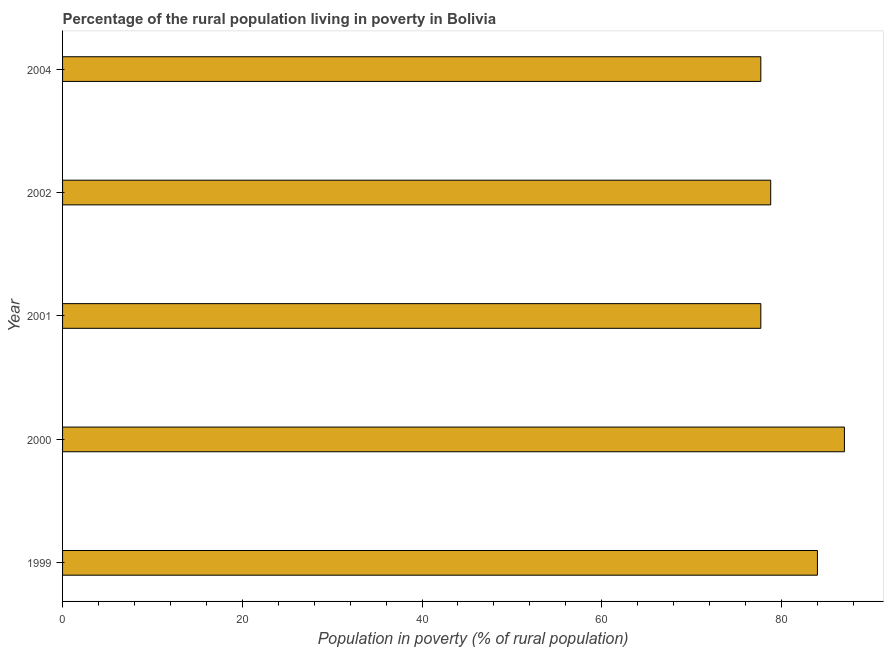What is the title of the graph?
Provide a succinct answer. Percentage of the rural population living in poverty in Bolivia. What is the label or title of the X-axis?
Offer a terse response. Population in poverty (% of rural population). What is the percentage of rural population living below poverty line in 2001?
Your response must be concise. 77.7. Across all years, what is the maximum percentage of rural population living below poverty line?
Provide a succinct answer. 87. Across all years, what is the minimum percentage of rural population living below poverty line?
Provide a succinct answer. 77.7. In which year was the percentage of rural population living below poverty line maximum?
Offer a very short reply. 2000. What is the sum of the percentage of rural population living below poverty line?
Give a very brief answer. 405.2. What is the difference between the percentage of rural population living below poverty line in 2000 and 2004?
Ensure brevity in your answer.  9.3. What is the average percentage of rural population living below poverty line per year?
Your answer should be very brief. 81.04. What is the median percentage of rural population living below poverty line?
Provide a succinct answer. 78.8. Do a majority of the years between 1999 and 2000 (inclusive) have percentage of rural population living below poverty line greater than 44 %?
Offer a very short reply. Yes. What is the ratio of the percentage of rural population living below poverty line in 2001 to that in 2002?
Offer a very short reply. 0.99. Is the percentage of rural population living below poverty line in 2001 less than that in 2002?
Provide a succinct answer. Yes. Is the difference between the percentage of rural population living below poverty line in 1999 and 2000 greater than the difference between any two years?
Give a very brief answer. No. What is the difference between the highest and the second highest percentage of rural population living below poverty line?
Your answer should be compact. 3. Is the sum of the percentage of rural population living below poverty line in 2000 and 2001 greater than the maximum percentage of rural population living below poverty line across all years?
Your response must be concise. Yes. What is the difference between the highest and the lowest percentage of rural population living below poverty line?
Your answer should be compact. 9.3. In how many years, is the percentage of rural population living below poverty line greater than the average percentage of rural population living below poverty line taken over all years?
Your answer should be compact. 2. What is the difference between two consecutive major ticks on the X-axis?
Your answer should be compact. 20. What is the Population in poverty (% of rural population) of 1999?
Offer a very short reply. 84. What is the Population in poverty (% of rural population) of 2001?
Your answer should be compact. 77.7. What is the Population in poverty (% of rural population) of 2002?
Provide a succinct answer. 78.8. What is the Population in poverty (% of rural population) of 2004?
Your answer should be compact. 77.7. What is the difference between the Population in poverty (% of rural population) in 1999 and 2000?
Keep it short and to the point. -3. What is the difference between the Population in poverty (% of rural population) in 2001 and 2004?
Provide a short and direct response. 0. What is the ratio of the Population in poverty (% of rural population) in 1999 to that in 2000?
Offer a terse response. 0.97. What is the ratio of the Population in poverty (% of rural population) in 1999 to that in 2001?
Give a very brief answer. 1.08. What is the ratio of the Population in poverty (% of rural population) in 1999 to that in 2002?
Your response must be concise. 1.07. What is the ratio of the Population in poverty (% of rural population) in 1999 to that in 2004?
Provide a short and direct response. 1.08. What is the ratio of the Population in poverty (% of rural population) in 2000 to that in 2001?
Provide a short and direct response. 1.12. What is the ratio of the Population in poverty (% of rural population) in 2000 to that in 2002?
Your answer should be very brief. 1.1. What is the ratio of the Population in poverty (% of rural population) in 2000 to that in 2004?
Your answer should be compact. 1.12. What is the ratio of the Population in poverty (% of rural population) in 2001 to that in 2004?
Offer a terse response. 1. What is the ratio of the Population in poverty (% of rural population) in 2002 to that in 2004?
Offer a terse response. 1.01. 